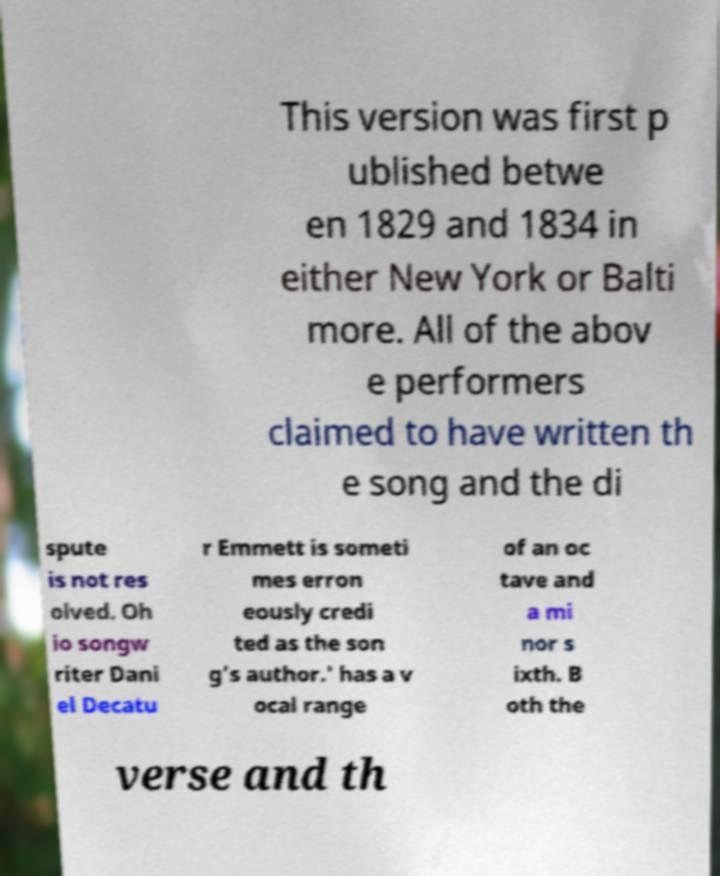For documentation purposes, I need the text within this image transcribed. Could you provide that? This version was first p ublished betwe en 1829 and 1834 in either New York or Balti more. All of the abov e performers claimed to have written th e song and the di spute is not res olved. Oh io songw riter Dani el Decatu r Emmett is someti mes erron eously credi ted as the son g's author.' has a v ocal range of an oc tave and a mi nor s ixth. B oth the verse and th 